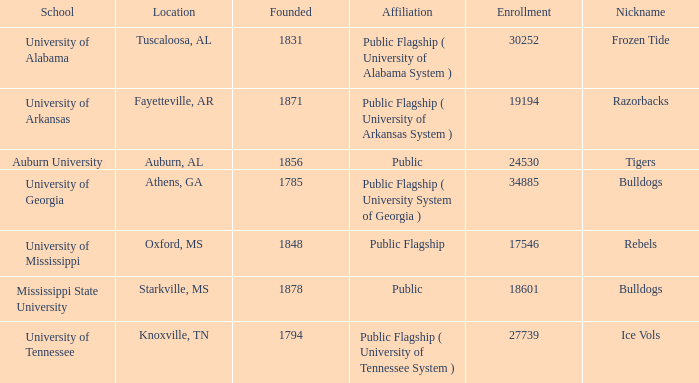What is the moniker of the university of alabama? Frozen Tide. 